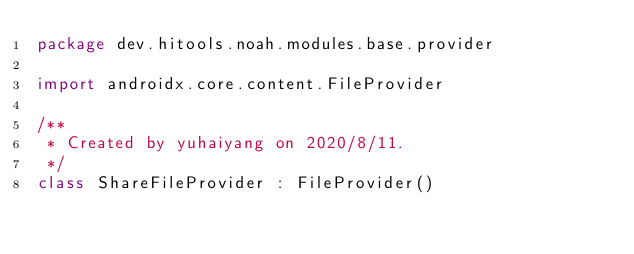Convert code to text. <code><loc_0><loc_0><loc_500><loc_500><_Kotlin_>package dev.hitools.noah.modules.base.provider

import androidx.core.content.FileProvider

/**
 * Created by yuhaiyang on 2020/8/11.
 */
class ShareFileProvider : FileProvider()</code> 